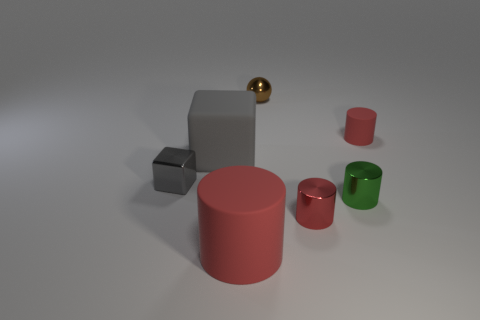What number of things are behind the big rubber thing on the left side of the red matte cylinder that is in front of the big gray rubber cube?
Keep it short and to the point. 2. There is a metallic cube that is the same size as the metallic sphere; what color is it?
Give a very brief answer. Gray. What is the size of the cylinder that is in front of the small red cylinder left of the tiny green object?
Ensure brevity in your answer.  Large. What size is the other metal cylinder that is the same color as the large cylinder?
Make the answer very short. Small. How many other things are the same size as the metallic cube?
Ensure brevity in your answer.  4. How many large cyan cylinders are there?
Provide a short and direct response. 0. Does the shiny ball have the same size as the green metallic thing?
Ensure brevity in your answer.  Yes. How many other things are there of the same shape as the green shiny object?
Make the answer very short. 3. The tiny red object that is behind the shiny thing that is to the left of the big red cylinder is made of what material?
Offer a very short reply. Rubber. Are there any tiny green metal cylinders behind the tiny brown metal ball?
Your answer should be compact. No. 